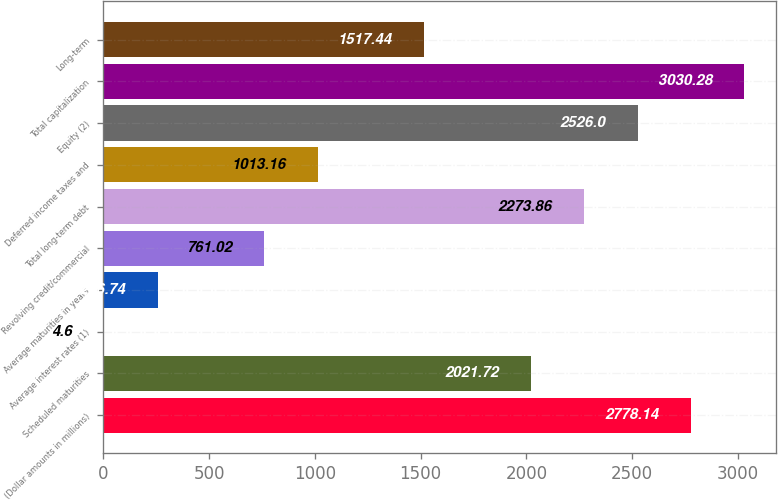Convert chart to OTSL. <chart><loc_0><loc_0><loc_500><loc_500><bar_chart><fcel>(Dollar amounts in millions)<fcel>Scheduled maturities<fcel>Average interest rates (1)<fcel>Average maturities in years<fcel>Revolving credit/commercial<fcel>Total long-term debt<fcel>Deferred income taxes and<fcel>Equity (2)<fcel>Total capitalization<fcel>Long-term<nl><fcel>2778.14<fcel>2021.72<fcel>4.6<fcel>256.74<fcel>761.02<fcel>2273.86<fcel>1013.16<fcel>2526<fcel>3030.28<fcel>1517.44<nl></chart> 